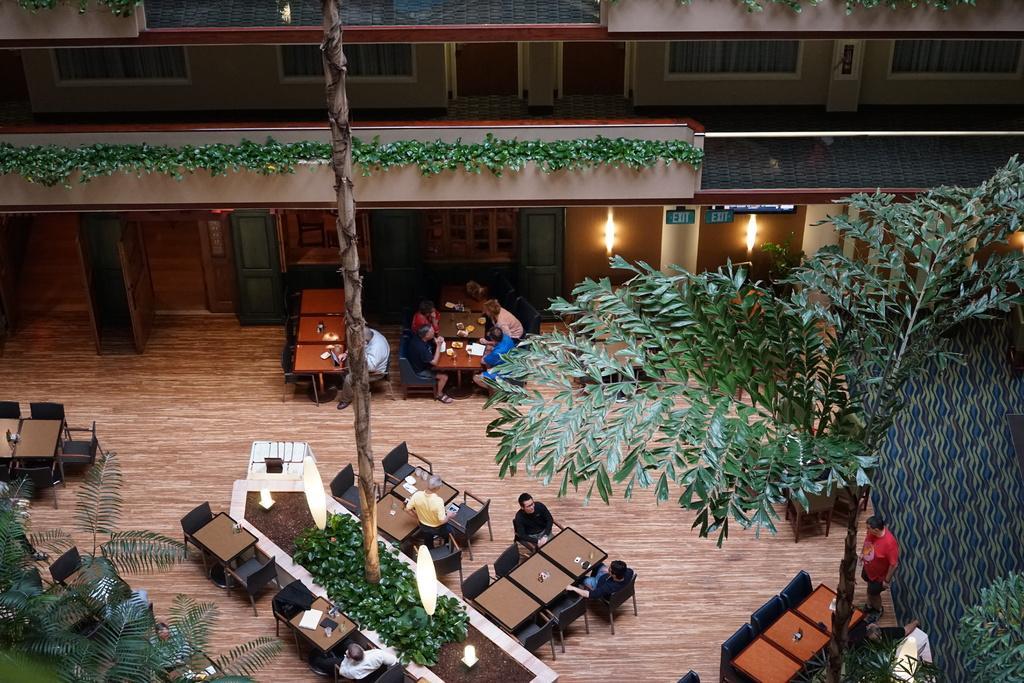Could you give a brief overview of what you see in this image? This is a top view and here we can see trees, tables, chairs and some people and glasses and papers and some other objects on the tables and there is a building and we can see creepers, lights, boards and there is a cloth. At the bottom, there is floor. 